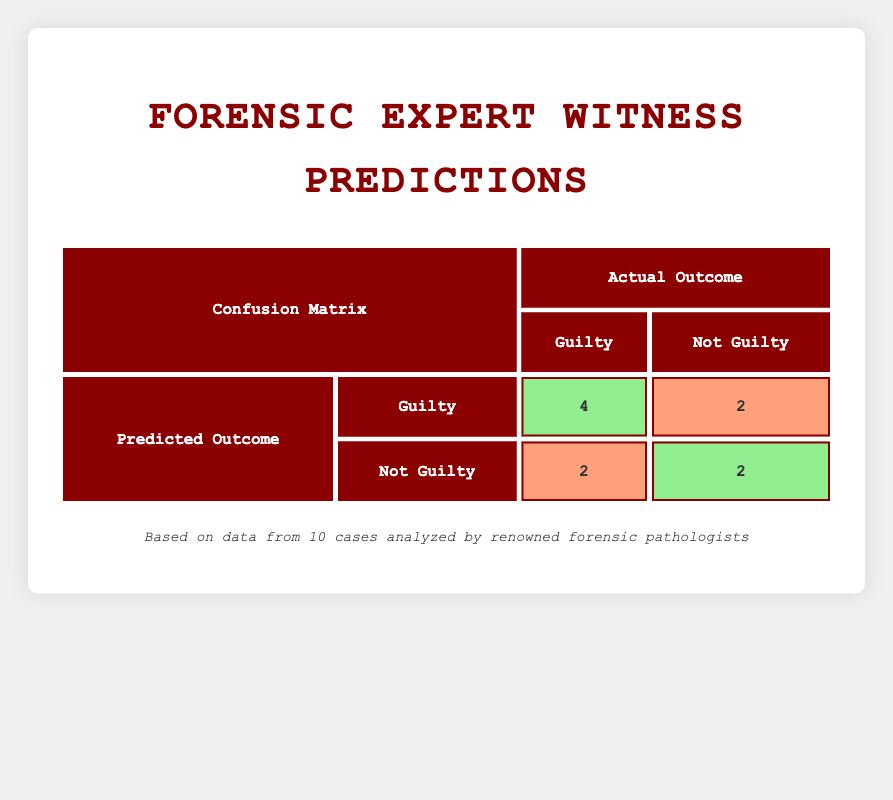What is the total number of true positives in the confusion matrix? The true positives are found in the cell corresponding to "Predicted Outcome: Guilty" and "Actual Outcome: Guilty". From the table, this value is 4.
Answer: 4 How many total cases were identified as "Not Guilty" by the forensic experts? The total number of cases identified as "Not Guilty" is the sum of true negatives (2) and false negatives (2), which gives 2 + 2 = 4.
Answer: 4 What is the count of false positives in the matrix? The false positives are located in the cell for "Predicted Outcome: Guilty" and "Actual Outcome: Not Guilty" from the table, which indicates a value of 2.
Answer: 2 Did Dr. Sarah Thompson correctly predict the outcome of her case? Dr. Sarah Thompson predicted "Guilty" and the actual outcome was also "Guilty". Therefore, her prediction was correct.
Answer: Yes What is the ratio of true negatives to false negatives in the confusion matrix? The ratio can be calculated by taking the number of true negatives (2) and dividing it by the number of false negatives (2), resulting in 2/2 = 1.
Answer: 1 How many predictions were made for "Guilty" overall? To find the total predictions made for "Guilty", add the true positives (4) and false positives (2), which is 4 + 2 = 6.
Answer: 6 Is the total number of predictions for "Not Guilty" equal to the total predictions for "Guilty"? From the previous questions, the total predictions for "Not Guilty" is 4 and for "Guilty" is 6. Therefore, they are not equal.
Answer: No How many expert witnesses incorrectly identified the case as "Not Guilty"? This is represented by the false positives (Dr. Lisa Chen, Dr. Michael Grant) who predicted "Not Guilty" but the actual outcome was "Guilty". There are 2 such cases.
Answer: 2 What is the total count of cases analyzed in the table? The total cases analyzed is simply the sum of all instances listed, which are 10 cases.
Answer: 10 